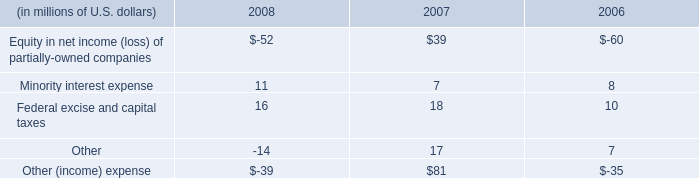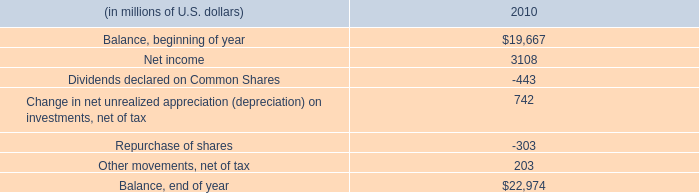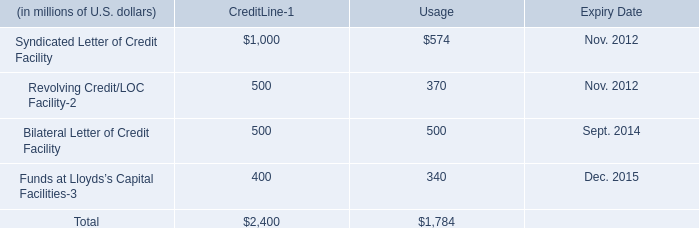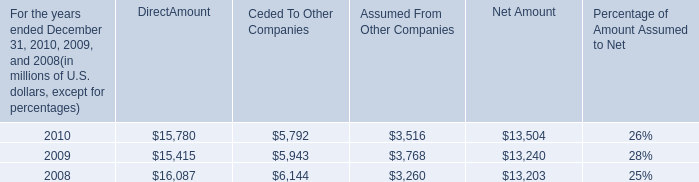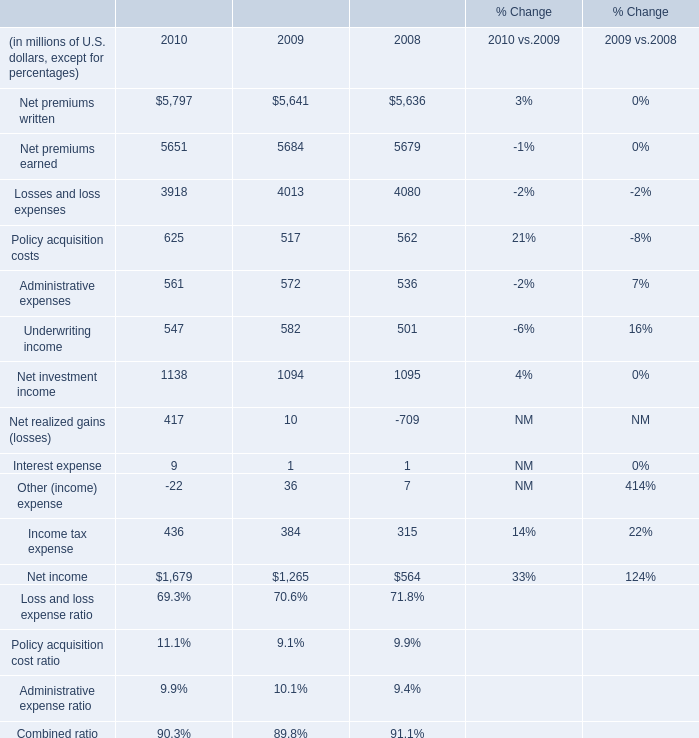in 2010 what was the percent of the credit utilization 
Computations: (1784 / 2400)
Answer: 0.74333. 